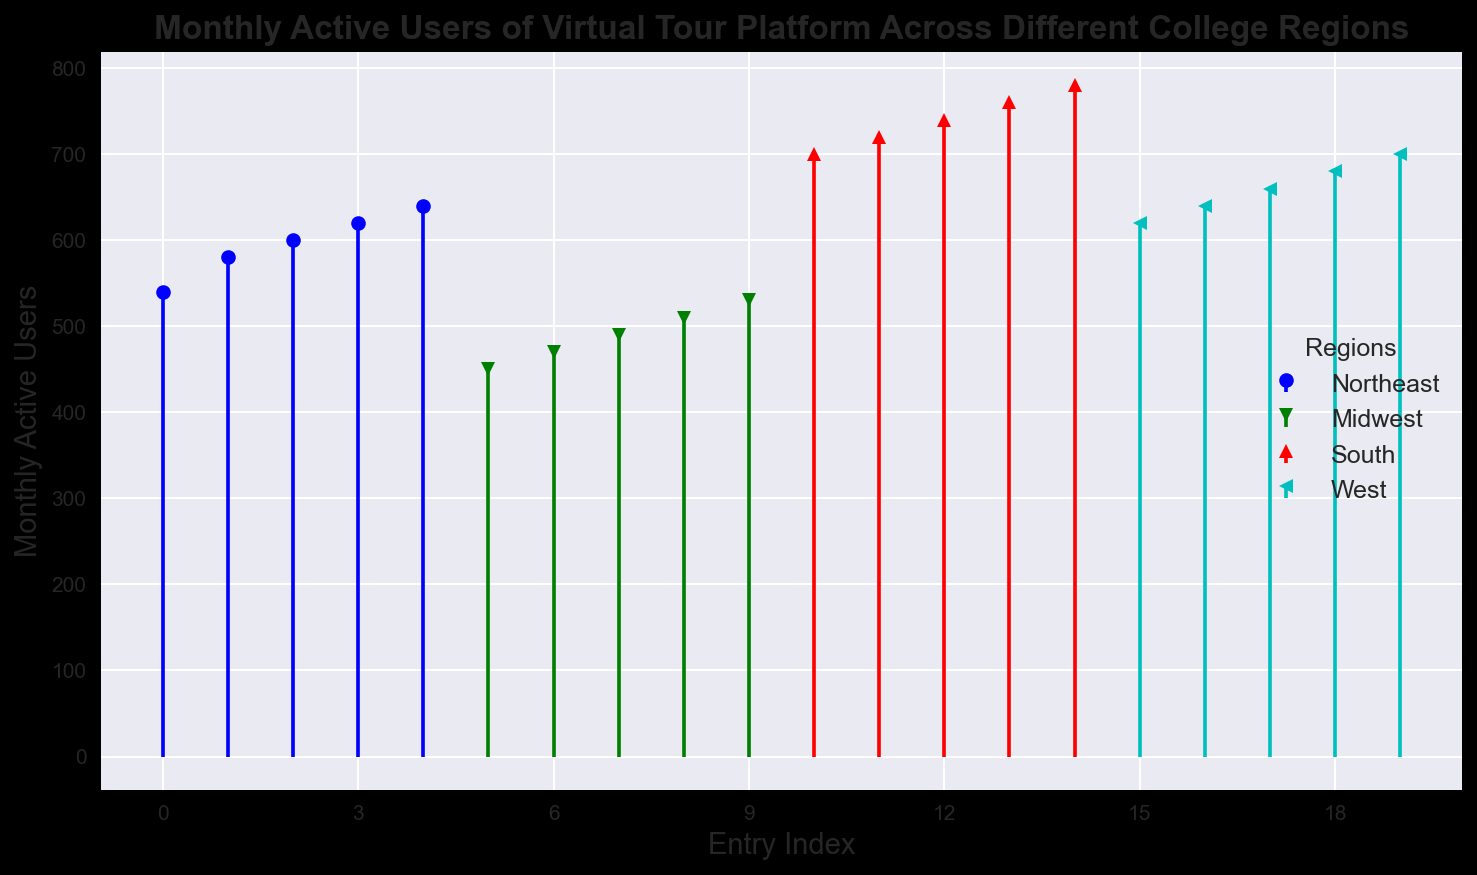What's the average number of monthly active users in the Northeast region? To calculate the average, sum all the values for the Northeast region and then divide by the number of values: (540 + 580 + 600 + 620 + 640) = 2980. Then, 2980 / 5 = 596
Answer: 596 Which region has the highest average number of monthly active users? Calculate the average for each region: 
Northeast: 596 
Midwest: (450 + 470 + 490 + 510 + 530) / 5 = 490 
South: (700 + 720 + 740 + 760 + 780) / 5 = 740 
West: (620 + 640 + 660 + 680 + 700) / 5 = 660. 
The South has the highest average
Answer: South Compare the range of monthly active users in the Midwest and West regions. Which is wider? The range is calculated as the difference between the maximum and minimum values. 
Midwest: 530 - 450 = 80 
West: 700 - 620 = 80. 
Both have the same range
Answer: Both have the same range Which region shows the most variation in monthly active users? Variation can often be seen by the range. Calculate the range for each region: 
Northeast: 640 - 540 = 100 
Midwest: 530 - 450 = 80 
South: 780 - 700 = 80 
West: 700 - 620 = 80. 
The Northeast has the most variation
Answer: Northeast How many regions have their lowest monthly active users below 500? By checking each region's lowest value: 
Northeast: 540 
Midwest: 450 
South: 700 
West: 620. 
Only the Midwest has values below 500
Answer: 1 Which region has the second smallest value of monthly active users? Identify the values for each region and sort them: 
Northeast: 540, 580, 600, 620, 640 
Midwest: 450, 470, 490, 510, 530 
South: 700, 720, 740, 760, 780 
West: 620, 640, 660, 680, 700. 
The second smallest value is 470
Answer: Midwest If we sum up the median values from each region, what will be the result? Find the median for each region (middle value in ordered data): 
Northeast: 600 
Midwest: 490 
South: 740 
West: 660. 
Sum: 600 + 490 + 740 + 660 = 2490
Answer: 2490 Which region's stem markers have a distinct shape compared to others? From the stem plot code, the Northeast has 'o' marker, Midwest has 'v', South has '^', and West has '<'. Each region has a distinct shape
Answer: Each region has a distinct shape 